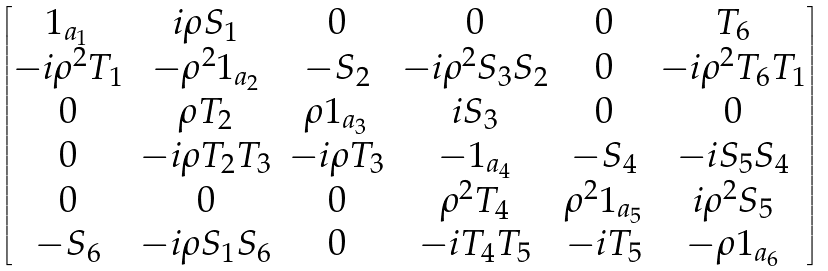Convert formula to latex. <formula><loc_0><loc_0><loc_500><loc_500>\begin{bmatrix} 1 _ { a _ { 1 } } & i \rho S _ { 1 } & 0 & 0 & 0 & T _ { 6 } \\ - i \rho ^ { 2 } T _ { 1 } & - \rho ^ { 2 } 1 _ { a _ { 2 } } & - S _ { 2 } & - i \rho ^ { 2 } S _ { 3 } S _ { 2 } & 0 & - i \rho ^ { 2 } T _ { 6 } T _ { 1 } \\ 0 & \rho T _ { 2 } & \rho 1 _ { a _ { 3 } } & i S _ { 3 } & 0 & 0 \\ 0 & - i \rho T _ { 2 } T _ { 3 } & - i \rho T _ { 3 } & - 1 _ { a _ { 4 } } & - S _ { 4 } & - i S _ { 5 } S _ { 4 } \\ 0 & 0 & 0 & \rho ^ { 2 } T _ { 4 } & \rho ^ { 2 } 1 _ { a _ { 5 } } & i \rho ^ { 2 } S _ { 5 } \\ - S _ { 6 } & - i \rho S _ { 1 } S _ { 6 } & 0 & - i T _ { 4 } T _ { 5 } & - i T _ { 5 } & - \rho 1 _ { a _ { 6 } } \end{bmatrix}</formula> 